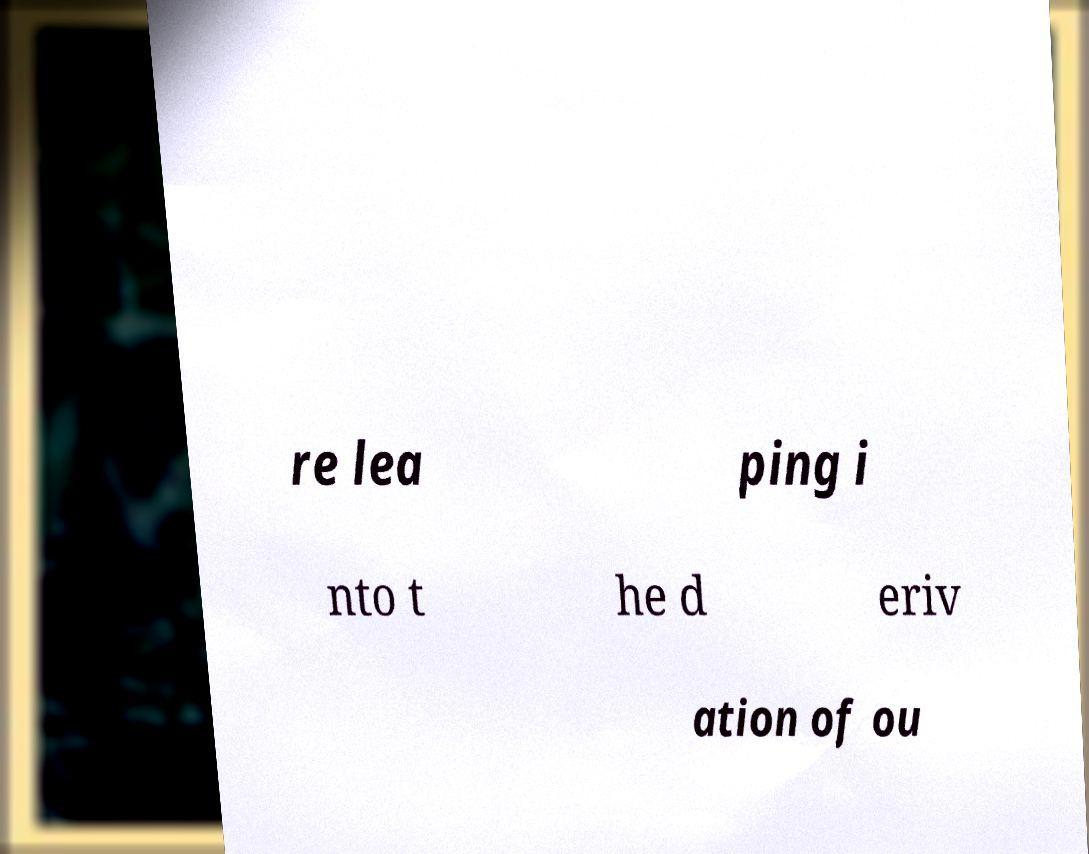I need the written content from this picture converted into text. Can you do that? re lea ping i nto t he d eriv ation of ou 